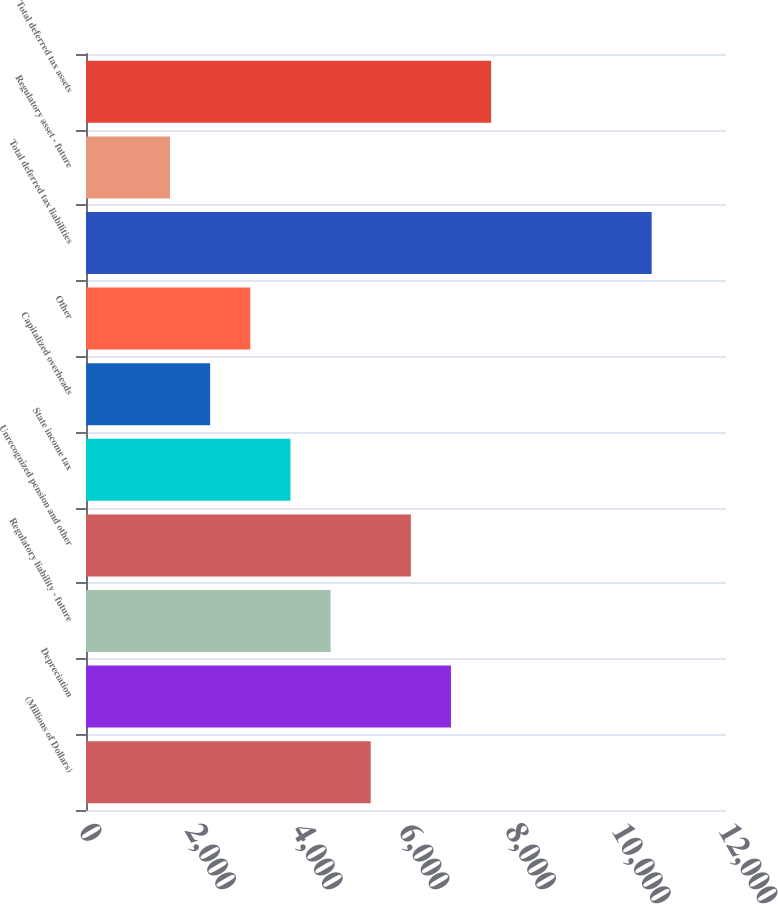Convert chart. <chart><loc_0><loc_0><loc_500><loc_500><bar_chart><fcel>(Millions of Dollars)<fcel>Depreciation<fcel>Regulatory liability - future<fcel>Unrecognized pension and other<fcel>State income tax<fcel>Capitalized overheads<fcel>Other<fcel>Total deferred tax liabilities<fcel>Regulatory asset - future<fcel>Total deferred tax assets<nl><fcel>5338.2<fcel>6843.4<fcel>4585.6<fcel>6090.8<fcel>3833<fcel>2327.8<fcel>3080.4<fcel>10606.4<fcel>1575.2<fcel>7596<nl></chart> 